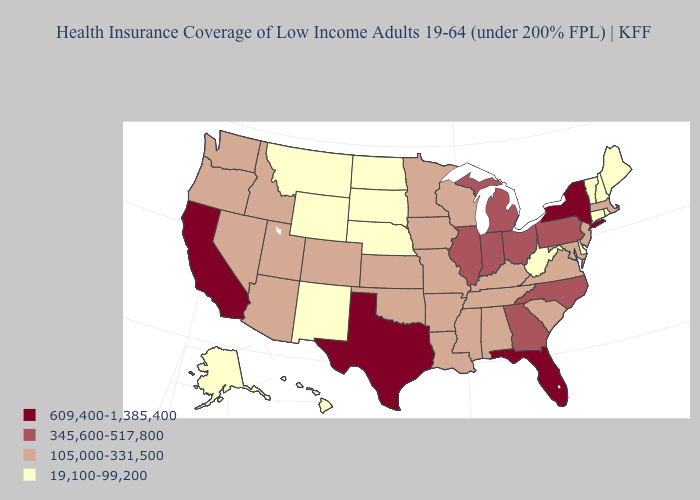What is the highest value in the USA?
Give a very brief answer. 609,400-1,385,400. Does the map have missing data?
Give a very brief answer. No. What is the value of Utah?
Concise answer only. 105,000-331,500. Name the states that have a value in the range 19,100-99,200?
Be succinct. Alaska, Connecticut, Delaware, Hawaii, Maine, Montana, Nebraska, New Hampshire, New Mexico, North Dakota, Rhode Island, South Dakota, Vermont, West Virginia, Wyoming. What is the value of Delaware?
Give a very brief answer. 19,100-99,200. Name the states that have a value in the range 105,000-331,500?
Answer briefly. Alabama, Arizona, Arkansas, Colorado, Idaho, Iowa, Kansas, Kentucky, Louisiana, Maryland, Massachusetts, Minnesota, Mississippi, Missouri, Nevada, New Jersey, Oklahoma, Oregon, South Carolina, Tennessee, Utah, Virginia, Washington, Wisconsin. Name the states that have a value in the range 105,000-331,500?
Give a very brief answer. Alabama, Arizona, Arkansas, Colorado, Idaho, Iowa, Kansas, Kentucky, Louisiana, Maryland, Massachusetts, Minnesota, Mississippi, Missouri, Nevada, New Jersey, Oklahoma, Oregon, South Carolina, Tennessee, Utah, Virginia, Washington, Wisconsin. What is the value of Nevada?
Quick response, please. 105,000-331,500. What is the value of Alabama?
Write a very short answer. 105,000-331,500. What is the value of New Hampshire?
Give a very brief answer. 19,100-99,200. What is the highest value in the South ?
Short answer required. 609,400-1,385,400. What is the value of Kentucky?
Short answer required. 105,000-331,500. Which states have the lowest value in the USA?
Concise answer only. Alaska, Connecticut, Delaware, Hawaii, Maine, Montana, Nebraska, New Hampshire, New Mexico, North Dakota, Rhode Island, South Dakota, Vermont, West Virginia, Wyoming. Name the states that have a value in the range 609,400-1,385,400?
Answer briefly. California, Florida, New York, Texas. What is the value of Nevada?
Keep it brief. 105,000-331,500. 